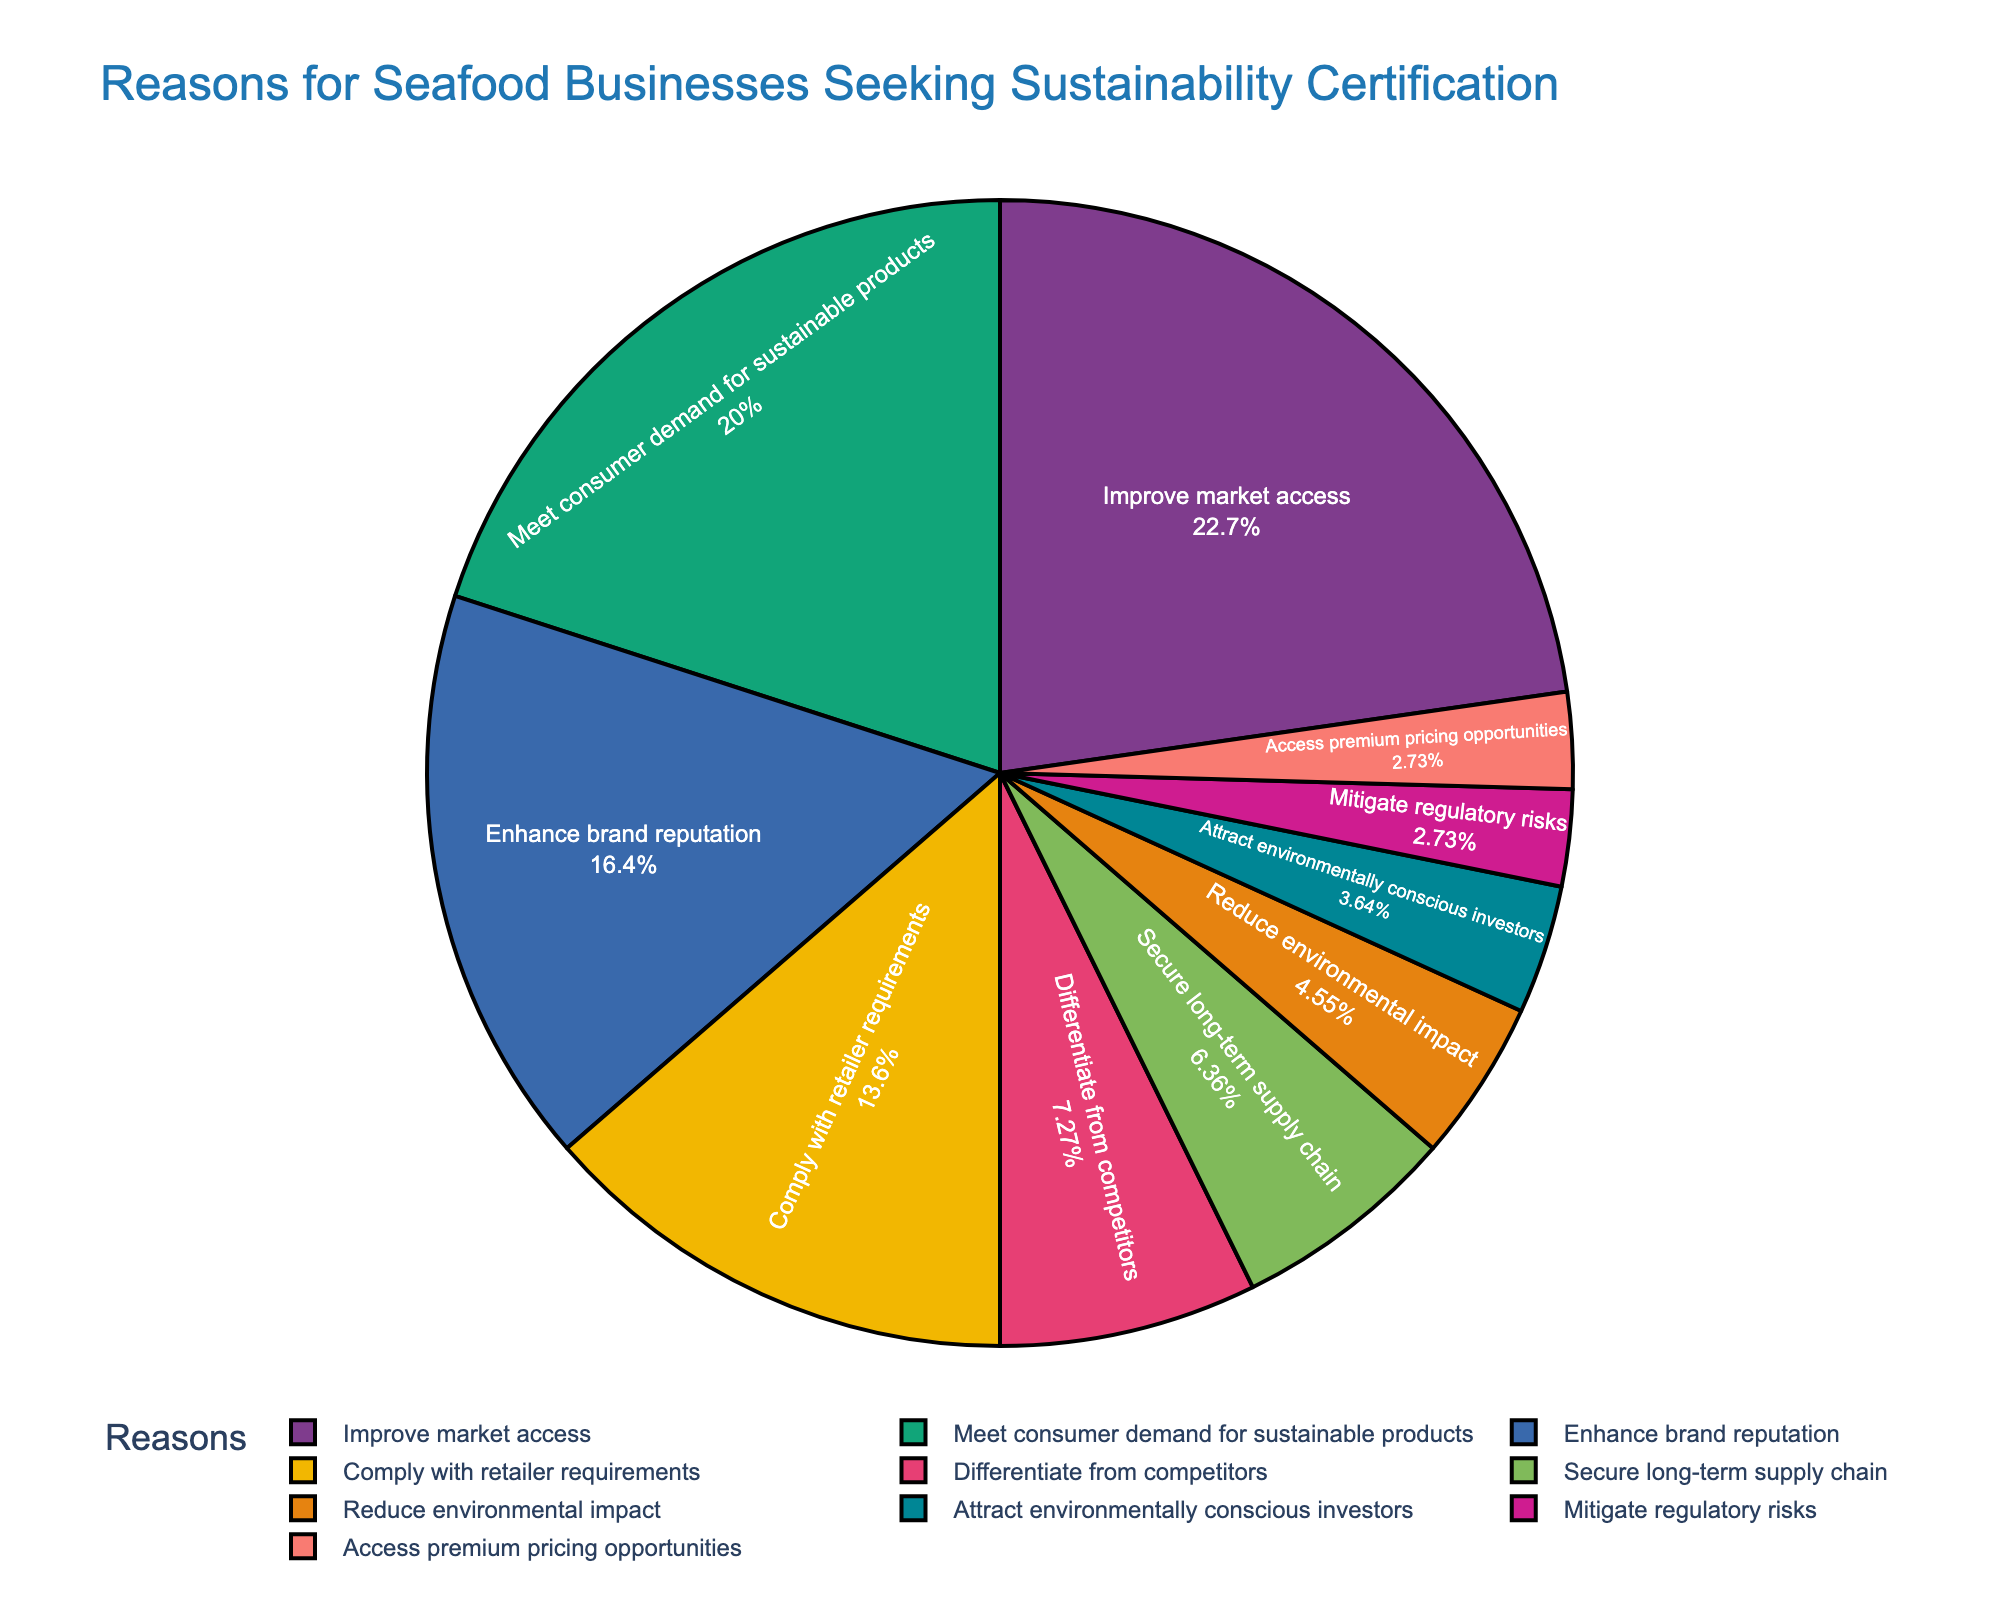What is the largest reason seafood businesses seek sustainability certification? The pie chart's largest segment represents the reason "Improve market access," with 25%.
Answer: Improve market access How much greater is the percentage of seafood businesses seeking certification to meet consumer demand compared to those doing so to enhance brand reputation? The percentage for meeting consumer demand is 22%, and for enhancing brand reputation, it is 18%. The difference is 22% - 18% = 4%.
Answer: 4% What are the two smallest reasons for seafood businesses seeking sustainability certification? The smallest segments on the pie chart represent "Mitigate regulatory risks" and "Access premium pricing opportunities," each with 3%.
Answer: Mitigate regulatory risks; Access premium pricing opportunities Which reason is represented by the red color segment? The pie chart's legend shows that the red segment corresponds to "Comply with retailer requirements."
Answer: Comply with retailer requirements If you combine the percentages of the three least common reasons, what is their total percentage? The three least common reasons are "Mitigate regulatory risks" (3%), "Access premium pricing opportunities" (3%), and "Attract environmentally conscious investors" (4%). Their total is 3% + 3% + 4% = 10%.
Answer: 10% What is the combined percentage of seafood businesses seeking certification to enhance brand reputation and differentiate from competitors? From the pie chart, enhance brand reputation is 18% and differentiate from competitors is 8%. The combined percentage is 18% + 8% = 26%.
Answer: 26% Which reason has a larger percentage: securing long-term supply chain or reducing environmental impact? The segment for secure long-term supply chain is 7%, and for reducing environmental impact, it is 5%. Therefore, securing long-term supply chain has a larger percentage.
Answer: Securing long-term supply chain Which reason is represented by a blue color segment? The pie chart's legend shows that the blue segment corresponds to the reason "Improve market access."
Answer: Improve market access How does the percentage of seafood businesses seeking certification to comply with retailer requirements compare to those wanting to differentiate from competitors? Comply with retailer requirements is 15%, and differentiate from competitors is 8%. Comparing them, 15% is greater than 8%.
Answer: Comply with retailer requirements is greater What percentage of seafood businesses seek certification for reasons other than improving market access? The total percentage of all reasons combined is 100%. The percentage for improving market access is 25%. Therefore, 100% - 25% = 75%.
Answer: 75% 